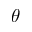Convert formula to latex. <formula><loc_0><loc_0><loc_500><loc_500>\theta</formula> 